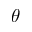Convert formula to latex. <formula><loc_0><loc_0><loc_500><loc_500>\theta</formula> 